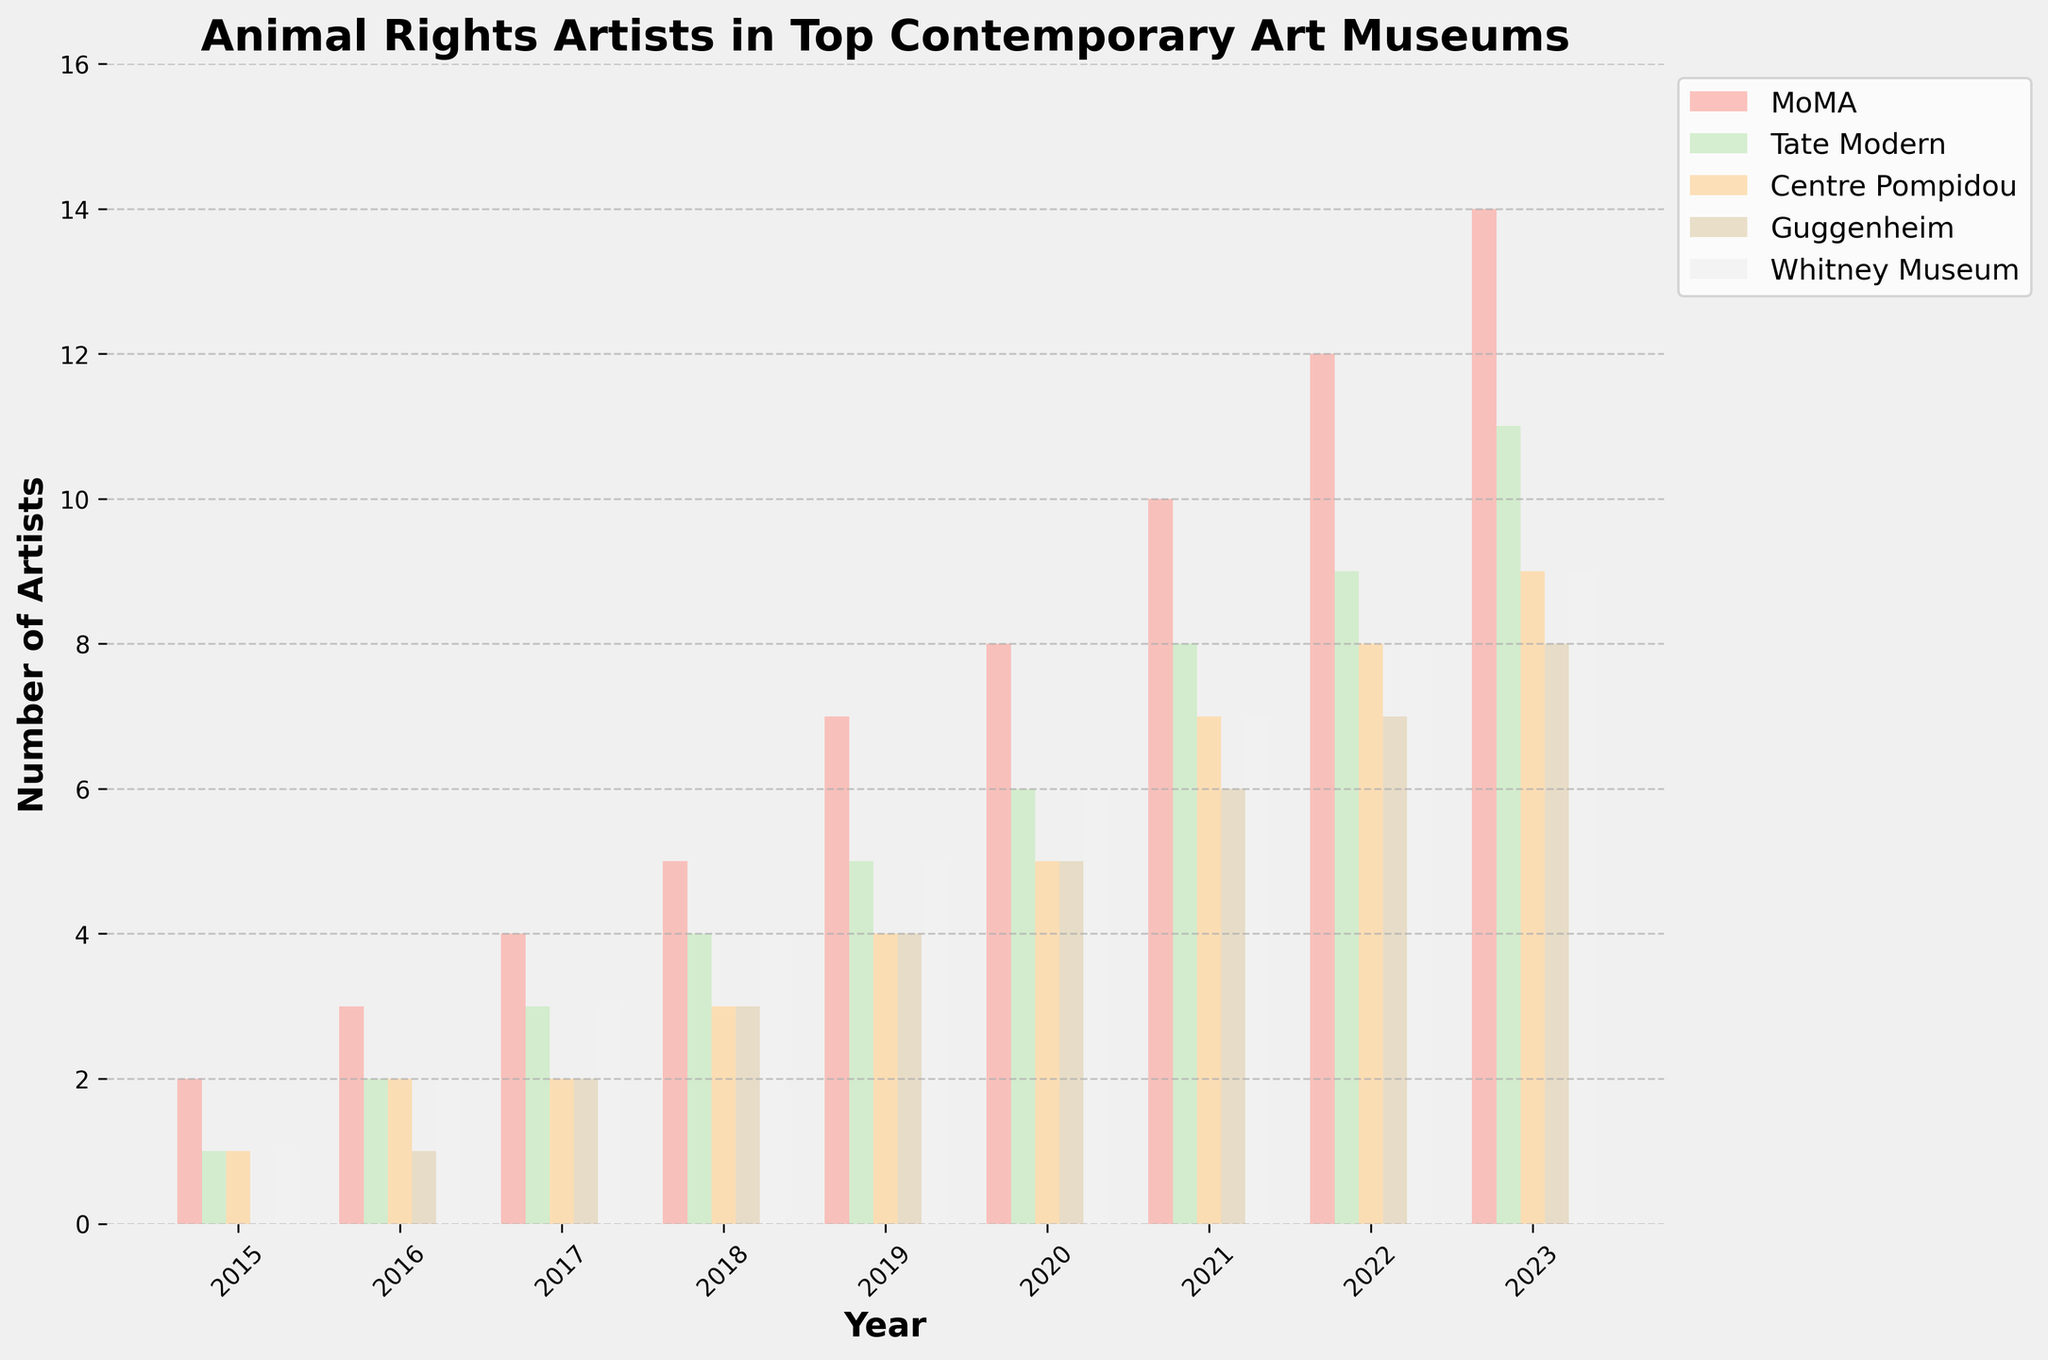Which museum features the most animal rights artists in 2023? To find the museum with the highest number of animal rights artists in 2023, look at the highest bar corresponding to the year 2023, which belongs to MoMA.
Answer: MoMA How many total animal rights artists were featured in 2020 across all museums? Add the numbers for all museums in 2020: MoMA (8), Tate Modern (6), Centre Pompidou (5), Guggenheim (5), and Whitney Museum (6). The total is 8 + 6 + 5 + 5 + 6 = 30.
Answer: 30 What is the trend in the number of animal rights artists featured at MoMA from 2015 to 2023? Observe the heights of the bars corresponding to MoMA from 2015 to 2023. The trend shows a steady increase from 2 in 2015 to 14 in 2023.
Answer: Steady increase Which museum had the smallest increase in the number of animal rights artists from 2015 to 2023? Calculate the difference between 2023 and 2015 values for each museum. MoMA: 14 - 2 = 12, Tate Modern: 11 - 1 = 10, Centre Pompidou: 9 - 1 = 8, Guggenheim: 8 - 0 = 8, Whitney Museum: 9 - 1 = 8. All three (Centre Pompidou, Guggenheim, and Whitney Museum) had an increase of 8.
Answer: Centre Pompidou, Guggenheim, Whitney Museum Which year shows the highest rate of increase in the number of animal rights artists featured at the Guggenheim? Compare the year-on-year differences for Guggenheim: 2016 (1-0=1), 2017 (2-1=1), 2018 (3-2=1), 2019 (4-3=1), 2020 (5-4=1), 2021 (6-5=1), 2022 (7-6=1), 2023 (8-7=1). Each year shows a consistent increase of 1.
Answer: No specific year (consistent increase of 1 each year) In which year did the Whitney Museum see the same number of animal rights artists as the Tate Modern? Compare the bars for Tate Modern and Whitney Museum across years. In 2021, Tate Modern and Whitney Museum both feature 8 artists.
Answer: 2021 On average, how many animal rights artists were featured per year at the Centre Pompidou from 2015 to 2023? Sum the values from 2015 to 2023 for Centre Pompidou: 1 + 2 + 2 + 3 + 4 + 5 + 7 + 8 + 9 = 41. Divide by 9 (number of years): 41/9 ≈ 4.56.
Answer: 4.56 Between 2015 and 2023, which museum had the largest fluctuation in the number of animal rights artists featured? Compare the range (max - min) for each museum over the years. MoMA: 14-2=12, Tate Modern: 11-1=10, Centre Pompidou: 9-1=8, Guggenheim: 8-0=8, Whitney Museum: 9-1=8. MoMA has the largest fluctuation with 12.
Answer: MoMA 